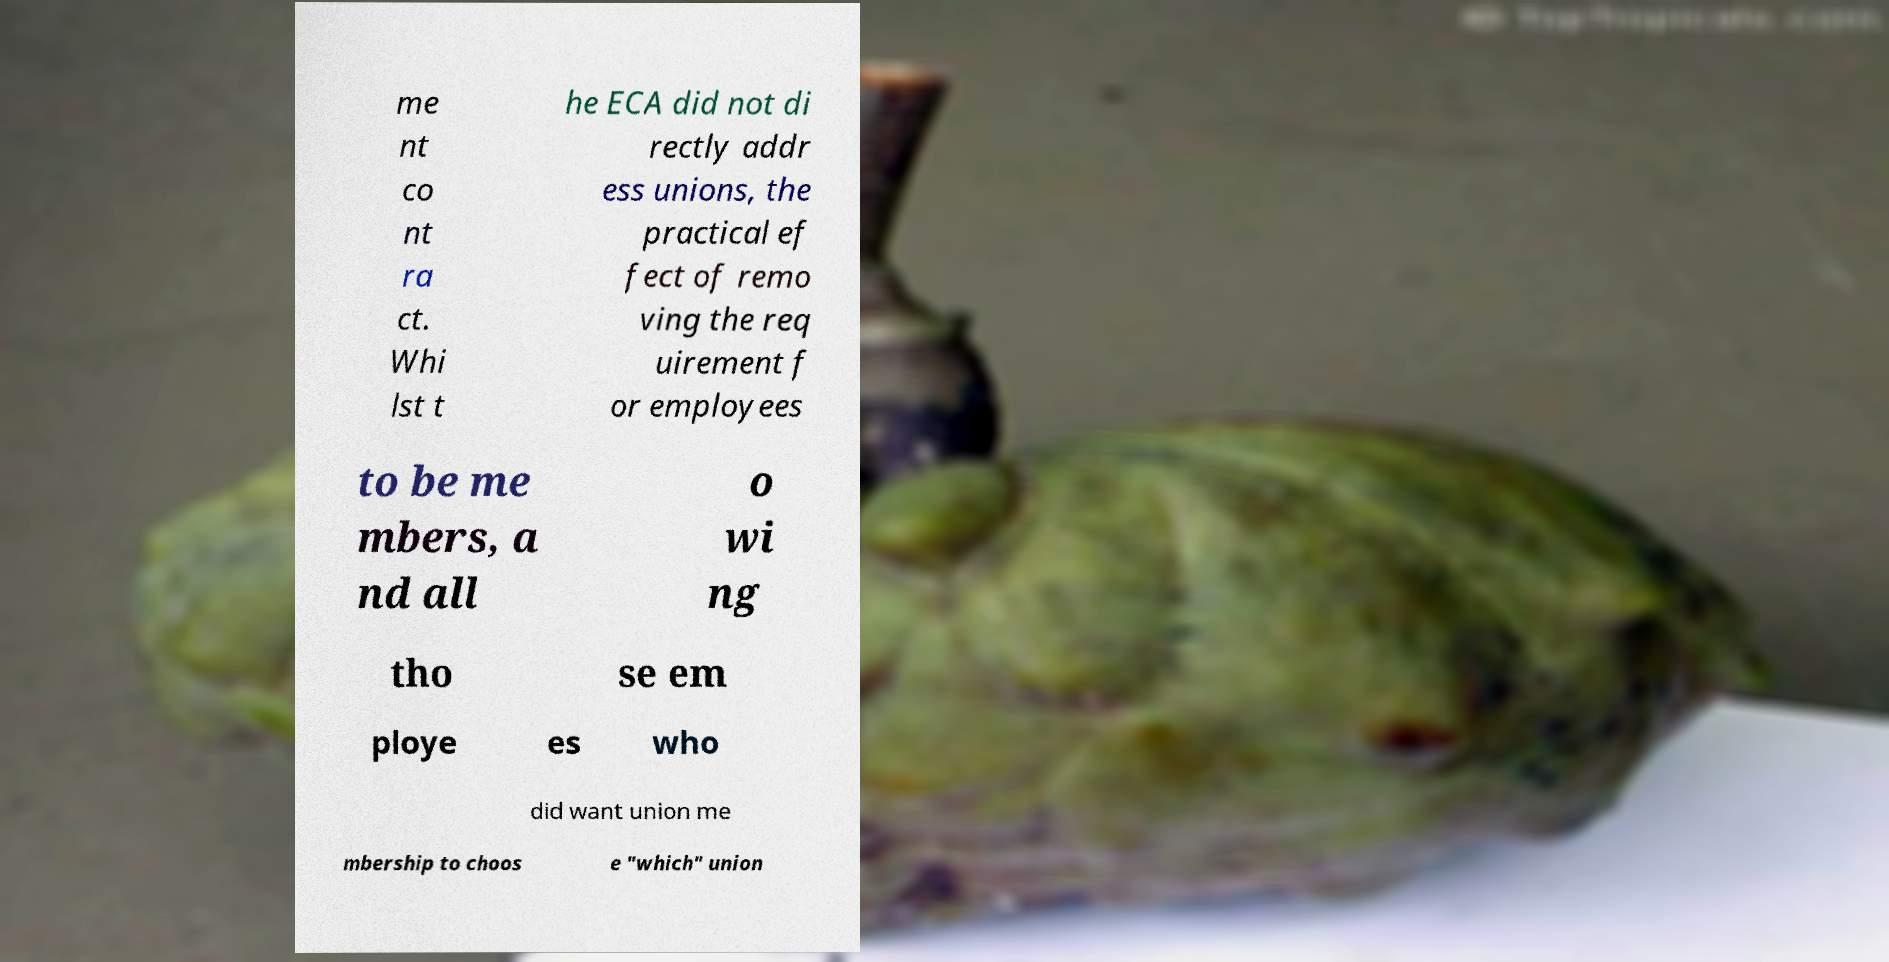Please identify and transcribe the text found in this image. me nt co nt ra ct. Whi lst t he ECA did not di rectly addr ess unions, the practical ef fect of remo ving the req uirement f or employees to be me mbers, a nd all o wi ng tho se em ploye es who did want union me mbership to choos e "which" union 